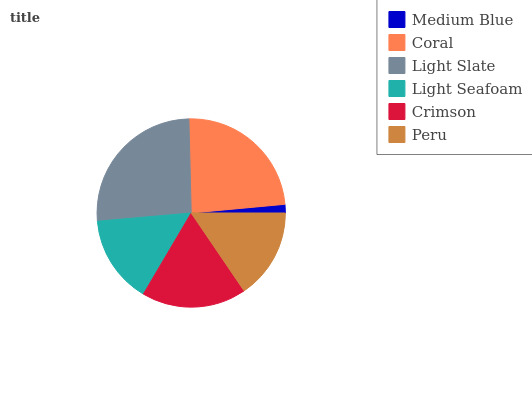Is Medium Blue the minimum?
Answer yes or no. Yes. Is Light Slate the maximum?
Answer yes or no. Yes. Is Coral the minimum?
Answer yes or no. No. Is Coral the maximum?
Answer yes or no. No. Is Coral greater than Medium Blue?
Answer yes or no. Yes. Is Medium Blue less than Coral?
Answer yes or no. Yes. Is Medium Blue greater than Coral?
Answer yes or no. No. Is Coral less than Medium Blue?
Answer yes or no. No. Is Crimson the high median?
Answer yes or no. Yes. Is Peru the low median?
Answer yes or no. Yes. Is Light Seafoam the high median?
Answer yes or no. No. Is Crimson the low median?
Answer yes or no. No. 